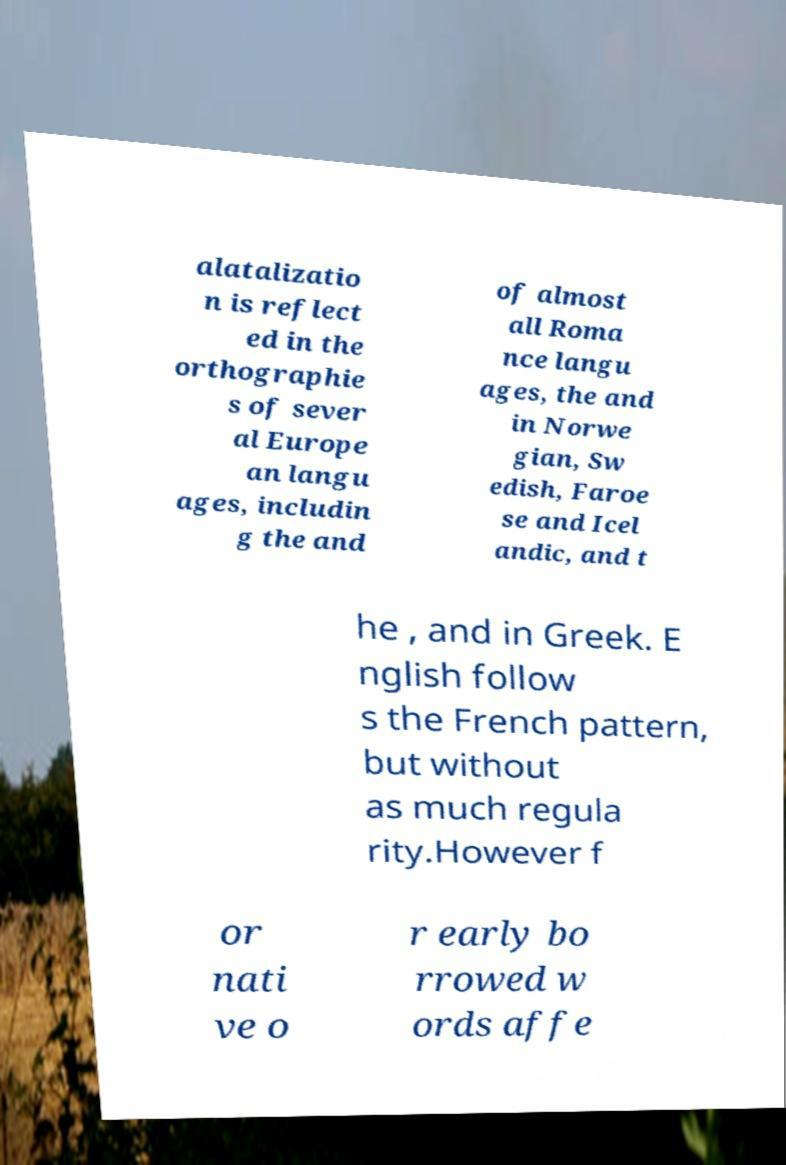Can you read and provide the text displayed in the image?This photo seems to have some interesting text. Can you extract and type it out for me? alatalizatio n is reflect ed in the orthographie s of sever al Europe an langu ages, includin g the and of almost all Roma nce langu ages, the and in Norwe gian, Sw edish, Faroe se and Icel andic, and t he , and in Greek. E nglish follow s the French pattern, but without as much regula rity.However f or nati ve o r early bo rrowed w ords affe 